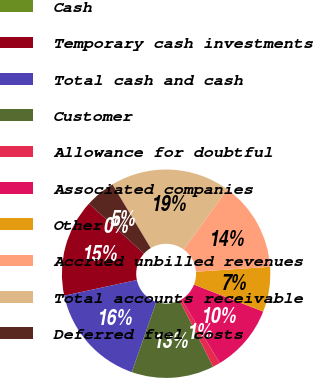Convert chart. <chart><loc_0><loc_0><loc_500><loc_500><pie_chart><fcel>Cash<fcel>Temporary cash investments<fcel>Total cash and cash<fcel>Customer<fcel>Allowance for doubtful<fcel>Associated companies<fcel>Other<fcel>Accrued unbilled revenues<fcel>Total accounts receivable<fcel>Deferred fuel costs<nl><fcel>0.0%<fcel>15.12%<fcel>16.28%<fcel>12.79%<fcel>1.16%<fcel>10.47%<fcel>6.98%<fcel>13.95%<fcel>18.6%<fcel>4.65%<nl></chart> 